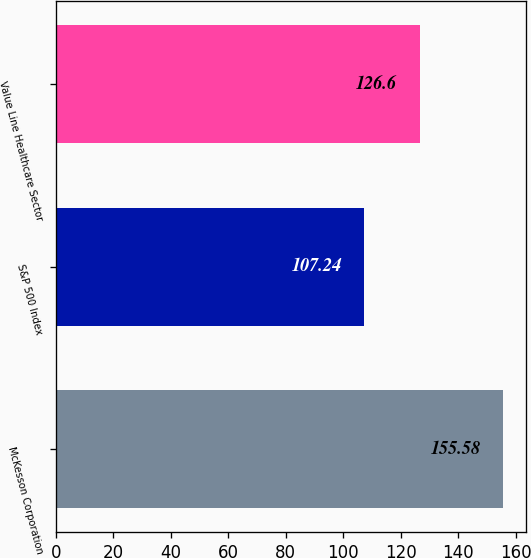Convert chart to OTSL. <chart><loc_0><loc_0><loc_500><loc_500><bar_chart><fcel>McKesson Corporation<fcel>S&P 500 Index<fcel>Value Line Healthcare Sector<nl><fcel>155.58<fcel>107.24<fcel>126.6<nl></chart> 